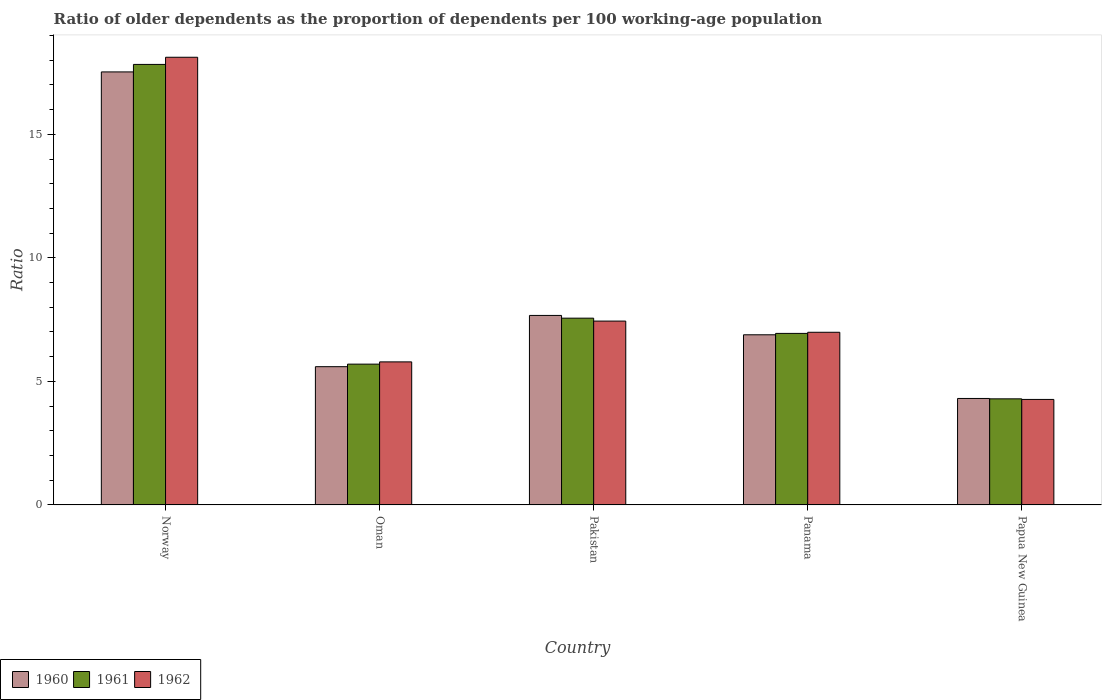How many different coloured bars are there?
Your answer should be very brief. 3. Are the number of bars per tick equal to the number of legend labels?
Provide a succinct answer. Yes. Are the number of bars on each tick of the X-axis equal?
Your response must be concise. Yes. How many bars are there on the 3rd tick from the left?
Offer a very short reply. 3. What is the age dependency ratio(old) in 1961 in Oman?
Make the answer very short. 5.7. Across all countries, what is the maximum age dependency ratio(old) in 1960?
Your response must be concise. 17.53. Across all countries, what is the minimum age dependency ratio(old) in 1961?
Give a very brief answer. 4.29. In which country was the age dependency ratio(old) in 1961 minimum?
Offer a terse response. Papua New Guinea. What is the total age dependency ratio(old) in 1962 in the graph?
Your response must be concise. 42.61. What is the difference between the age dependency ratio(old) in 1962 in Oman and that in Pakistan?
Offer a very short reply. -1.65. What is the difference between the age dependency ratio(old) in 1960 in Papua New Guinea and the age dependency ratio(old) in 1961 in Norway?
Make the answer very short. -13.52. What is the average age dependency ratio(old) in 1962 per country?
Your answer should be very brief. 8.52. What is the difference between the age dependency ratio(old) of/in 1960 and age dependency ratio(old) of/in 1961 in Panama?
Your answer should be very brief. -0.06. In how many countries, is the age dependency ratio(old) in 1960 greater than 18?
Offer a very short reply. 0. What is the ratio of the age dependency ratio(old) in 1961 in Pakistan to that in Papua New Guinea?
Offer a very short reply. 1.76. Is the age dependency ratio(old) in 1962 in Norway less than that in Panama?
Offer a very short reply. No. What is the difference between the highest and the second highest age dependency ratio(old) in 1960?
Provide a succinct answer. 10.64. What is the difference between the highest and the lowest age dependency ratio(old) in 1960?
Your answer should be very brief. 13.22. In how many countries, is the age dependency ratio(old) in 1962 greater than the average age dependency ratio(old) in 1962 taken over all countries?
Your answer should be compact. 1. What does the 3rd bar from the right in Oman represents?
Offer a very short reply. 1960. Are all the bars in the graph horizontal?
Make the answer very short. No. How many countries are there in the graph?
Your response must be concise. 5. Are the values on the major ticks of Y-axis written in scientific E-notation?
Your response must be concise. No. Does the graph contain grids?
Offer a very short reply. No. How are the legend labels stacked?
Provide a short and direct response. Horizontal. What is the title of the graph?
Provide a succinct answer. Ratio of older dependents as the proportion of dependents per 100 working-age population. What is the label or title of the Y-axis?
Keep it short and to the point. Ratio. What is the Ratio in 1960 in Norway?
Your response must be concise. 17.53. What is the Ratio of 1961 in Norway?
Keep it short and to the point. 17.83. What is the Ratio in 1962 in Norway?
Make the answer very short. 18.12. What is the Ratio in 1960 in Oman?
Offer a very short reply. 5.6. What is the Ratio in 1961 in Oman?
Your answer should be compact. 5.7. What is the Ratio of 1962 in Oman?
Give a very brief answer. 5.79. What is the Ratio in 1960 in Pakistan?
Provide a succinct answer. 7.67. What is the Ratio of 1961 in Pakistan?
Provide a short and direct response. 7.56. What is the Ratio in 1962 in Pakistan?
Ensure brevity in your answer.  7.44. What is the Ratio of 1960 in Panama?
Provide a succinct answer. 6.89. What is the Ratio of 1961 in Panama?
Your answer should be very brief. 6.94. What is the Ratio in 1962 in Panama?
Your answer should be compact. 6.99. What is the Ratio of 1960 in Papua New Guinea?
Your answer should be compact. 4.31. What is the Ratio of 1961 in Papua New Guinea?
Give a very brief answer. 4.29. What is the Ratio of 1962 in Papua New Guinea?
Offer a very short reply. 4.27. Across all countries, what is the maximum Ratio of 1960?
Ensure brevity in your answer.  17.53. Across all countries, what is the maximum Ratio of 1961?
Offer a very short reply. 17.83. Across all countries, what is the maximum Ratio of 1962?
Offer a terse response. 18.12. Across all countries, what is the minimum Ratio of 1960?
Your answer should be very brief. 4.31. Across all countries, what is the minimum Ratio in 1961?
Your answer should be compact. 4.29. Across all countries, what is the minimum Ratio in 1962?
Offer a terse response. 4.27. What is the total Ratio of 1960 in the graph?
Provide a succinct answer. 41.99. What is the total Ratio in 1961 in the graph?
Provide a succinct answer. 42.33. What is the total Ratio of 1962 in the graph?
Your answer should be compact. 42.61. What is the difference between the Ratio in 1960 in Norway and that in Oman?
Your answer should be compact. 11.93. What is the difference between the Ratio in 1961 in Norway and that in Oman?
Offer a terse response. 12.13. What is the difference between the Ratio of 1962 in Norway and that in Oman?
Your answer should be very brief. 12.33. What is the difference between the Ratio in 1960 in Norway and that in Pakistan?
Your answer should be compact. 9.86. What is the difference between the Ratio in 1961 in Norway and that in Pakistan?
Offer a very short reply. 10.27. What is the difference between the Ratio in 1962 in Norway and that in Pakistan?
Ensure brevity in your answer.  10.68. What is the difference between the Ratio of 1960 in Norway and that in Panama?
Provide a succinct answer. 10.64. What is the difference between the Ratio in 1961 in Norway and that in Panama?
Keep it short and to the point. 10.89. What is the difference between the Ratio in 1962 in Norway and that in Panama?
Your response must be concise. 11.13. What is the difference between the Ratio in 1960 in Norway and that in Papua New Guinea?
Make the answer very short. 13.22. What is the difference between the Ratio of 1961 in Norway and that in Papua New Guinea?
Make the answer very short. 13.54. What is the difference between the Ratio of 1962 in Norway and that in Papua New Guinea?
Offer a very short reply. 13.85. What is the difference between the Ratio of 1960 in Oman and that in Pakistan?
Ensure brevity in your answer.  -2.07. What is the difference between the Ratio in 1961 in Oman and that in Pakistan?
Provide a short and direct response. -1.86. What is the difference between the Ratio of 1962 in Oman and that in Pakistan?
Make the answer very short. -1.65. What is the difference between the Ratio of 1960 in Oman and that in Panama?
Provide a short and direct response. -1.29. What is the difference between the Ratio of 1961 in Oman and that in Panama?
Make the answer very short. -1.24. What is the difference between the Ratio in 1962 in Oman and that in Panama?
Provide a short and direct response. -1.2. What is the difference between the Ratio in 1960 in Oman and that in Papua New Guinea?
Make the answer very short. 1.29. What is the difference between the Ratio of 1961 in Oman and that in Papua New Guinea?
Offer a very short reply. 1.4. What is the difference between the Ratio of 1962 in Oman and that in Papua New Guinea?
Offer a very short reply. 1.52. What is the difference between the Ratio in 1960 in Pakistan and that in Panama?
Your answer should be very brief. 0.78. What is the difference between the Ratio of 1961 in Pakistan and that in Panama?
Your response must be concise. 0.62. What is the difference between the Ratio of 1962 in Pakistan and that in Panama?
Provide a short and direct response. 0.45. What is the difference between the Ratio in 1960 in Pakistan and that in Papua New Guinea?
Provide a succinct answer. 3.36. What is the difference between the Ratio in 1961 in Pakistan and that in Papua New Guinea?
Offer a terse response. 3.27. What is the difference between the Ratio of 1962 in Pakistan and that in Papua New Guinea?
Offer a terse response. 3.17. What is the difference between the Ratio of 1960 in Panama and that in Papua New Guinea?
Your answer should be very brief. 2.58. What is the difference between the Ratio of 1961 in Panama and that in Papua New Guinea?
Offer a very short reply. 2.65. What is the difference between the Ratio in 1962 in Panama and that in Papua New Guinea?
Give a very brief answer. 2.72. What is the difference between the Ratio of 1960 in Norway and the Ratio of 1961 in Oman?
Your answer should be very brief. 11.83. What is the difference between the Ratio in 1960 in Norway and the Ratio in 1962 in Oman?
Offer a very short reply. 11.74. What is the difference between the Ratio in 1961 in Norway and the Ratio in 1962 in Oman?
Offer a very short reply. 12.04. What is the difference between the Ratio in 1960 in Norway and the Ratio in 1961 in Pakistan?
Provide a short and direct response. 9.97. What is the difference between the Ratio of 1960 in Norway and the Ratio of 1962 in Pakistan?
Ensure brevity in your answer.  10.09. What is the difference between the Ratio in 1961 in Norway and the Ratio in 1962 in Pakistan?
Your answer should be compact. 10.39. What is the difference between the Ratio of 1960 in Norway and the Ratio of 1961 in Panama?
Ensure brevity in your answer.  10.58. What is the difference between the Ratio of 1960 in Norway and the Ratio of 1962 in Panama?
Keep it short and to the point. 10.54. What is the difference between the Ratio of 1961 in Norway and the Ratio of 1962 in Panama?
Offer a very short reply. 10.84. What is the difference between the Ratio in 1960 in Norway and the Ratio in 1961 in Papua New Guinea?
Your answer should be compact. 13.23. What is the difference between the Ratio of 1960 in Norway and the Ratio of 1962 in Papua New Guinea?
Ensure brevity in your answer.  13.26. What is the difference between the Ratio of 1961 in Norway and the Ratio of 1962 in Papua New Guinea?
Provide a short and direct response. 13.56. What is the difference between the Ratio of 1960 in Oman and the Ratio of 1961 in Pakistan?
Keep it short and to the point. -1.96. What is the difference between the Ratio of 1960 in Oman and the Ratio of 1962 in Pakistan?
Ensure brevity in your answer.  -1.85. What is the difference between the Ratio of 1961 in Oman and the Ratio of 1962 in Pakistan?
Provide a short and direct response. -1.74. What is the difference between the Ratio in 1960 in Oman and the Ratio in 1961 in Panama?
Offer a terse response. -1.35. What is the difference between the Ratio in 1960 in Oman and the Ratio in 1962 in Panama?
Give a very brief answer. -1.39. What is the difference between the Ratio of 1961 in Oman and the Ratio of 1962 in Panama?
Offer a very short reply. -1.29. What is the difference between the Ratio of 1960 in Oman and the Ratio of 1961 in Papua New Guinea?
Your response must be concise. 1.3. What is the difference between the Ratio of 1960 in Oman and the Ratio of 1962 in Papua New Guinea?
Your answer should be very brief. 1.33. What is the difference between the Ratio in 1961 in Oman and the Ratio in 1962 in Papua New Guinea?
Your answer should be very brief. 1.43. What is the difference between the Ratio in 1960 in Pakistan and the Ratio in 1961 in Panama?
Provide a short and direct response. 0.73. What is the difference between the Ratio of 1960 in Pakistan and the Ratio of 1962 in Panama?
Ensure brevity in your answer.  0.68. What is the difference between the Ratio in 1961 in Pakistan and the Ratio in 1962 in Panama?
Ensure brevity in your answer.  0.57. What is the difference between the Ratio in 1960 in Pakistan and the Ratio in 1961 in Papua New Guinea?
Provide a short and direct response. 3.38. What is the difference between the Ratio of 1960 in Pakistan and the Ratio of 1962 in Papua New Guinea?
Keep it short and to the point. 3.4. What is the difference between the Ratio in 1961 in Pakistan and the Ratio in 1962 in Papua New Guinea?
Keep it short and to the point. 3.29. What is the difference between the Ratio in 1960 in Panama and the Ratio in 1961 in Papua New Guinea?
Make the answer very short. 2.59. What is the difference between the Ratio in 1960 in Panama and the Ratio in 1962 in Papua New Guinea?
Your answer should be compact. 2.62. What is the difference between the Ratio of 1961 in Panama and the Ratio of 1962 in Papua New Guinea?
Give a very brief answer. 2.67. What is the average Ratio in 1960 per country?
Make the answer very short. 8.4. What is the average Ratio in 1961 per country?
Offer a terse response. 8.47. What is the average Ratio of 1962 per country?
Keep it short and to the point. 8.52. What is the difference between the Ratio of 1960 and Ratio of 1961 in Norway?
Offer a terse response. -0.3. What is the difference between the Ratio of 1960 and Ratio of 1962 in Norway?
Offer a terse response. -0.59. What is the difference between the Ratio in 1961 and Ratio in 1962 in Norway?
Your answer should be compact. -0.29. What is the difference between the Ratio in 1960 and Ratio in 1961 in Oman?
Your response must be concise. -0.1. What is the difference between the Ratio in 1960 and Ratio in 1962 in Oman?
Your response must be concise. -0.19. What is the difference between the Ratio in 1961 and Ratio in 1962 in Oman?
Offer a terse response. -0.09. What is the difference between the Ratio of 1960 and Ratio of 1961 in Pakistan?
Offer a very short reply. 0.11. What is the difference between the Ratio of 1960 and Ratio of 1962 in Pakistan?
Offer a very short reply. 0.23. What is the difference between the Ratio in 1961 and Ratio in 1962 in Pakistan?
Keep it short and to the point. 0.12. What is the difference between the Ratio of 1960 and Ratio of 1961 in Panama?
Offer a very short reply. -0.06. What is the difference between the Ratio of 1960 and Ratio of 1962 in Panama?
Offer a terse response. -0.1. What is the difference between the Ratio of 1961 and Ratio of 1962 in Panama?
Make the answer very short. -0.05. What is the difference between the Ratio in 1960 and Ratio in 1961 in Papua New Guinea?
Provide a short and direct response. 0.02. What is the difference between the Ratio in 1960 and Ratio in 1962 in Papua New Guinea?
Ensure brevity in your answer.  0.04. What is the difference between the Ratio of 1961 and Ratio of 1962 in Papua New Guinea?
Your answer should be compact. 0.02. What is the ratio of the Ratio of 1960 in Norway to that in Oman?
Your answer should be compact. 3.13. What is the ratio of the Ratio of 1961 in Norway to that in Oman?
Provide a short and direct response. 3.13. What is the ratio of the Ratio of 1962 in Norway to that in Oman?
Your answer should be compact. 3.13. What is the ratio of the Ratio in 1960 in Norway to that in Pakistan?
Your answer should be very brief. 2.28. What is the ratio of the Ratio in 1961 in Norway to that in Pakistan?
Offer a terse response. 2.36. What is the ratio of the Ratio of 1962 in Norway to that in Pakistan?
Your answer should be very brief. 2.44. What is the ratio of the Ratio of 1960 in Norway to that in Panama?
Make the answer very short. 2.55. What is the ratio of the Ratio of 1961 in Norway to that in Panama?
Your answer should be very brief. 2.57. What is the ratio of the Ratio of 1962 in Norway to that in Panama?
Keep it short and to the point. 2.59. What is the ratio of the Ratio of 1960 in Norway to that in Papua New Guinea?
Provide a short and direct response. 4.07. What is the ratio of the Ratio in 1961 in Norway to that in Papua New Guinea?
Provide a short and direct response. 4.15. What is the ratio of the Ratio in 1962 in Norway to that in Papua New Guinea?
Make the answer very short. 4.24. What is the ratio of the Ratio of 1960 in Oman to that in Pakistan?
Provide a succinct answer. 0.73. What is the ratio of the Ratio of 1961 in Oman to that in Pakistan?
Your answer should be compact. 0.75. What is the ratio of the Ratio of 1962 in Oman to that in Pakistan?
Make the answer very short. 0.78. What is the ratio of the Ratio in 1960 in Oman to that in Panama?
Make the answer very short. 0.81. What is the ratio of the Ratio in 1961 in Oman to that in Panama?
Offer a terse response. 0.82. What is the ratio of the Ratio in 1962 in Oman to that in Panama?
Give a very brief answer. 0.83. What is the ratio of the Ratio in 1960 in Oman to that in Papua New Guinea?
Offer a very short reply. 1.3. What is the ratio of the Ratio in 1961 in Oman to that in Papua New Guinea?
Your response must be concise. 1.33. What is the ratio of the Ratio in 1962 in Oman to that in Papua New Guinea?
Provide a succinct answer. 1.36. What is the ratio of the Ratio of 1960 in Pakistan to that in Panama?
Your response must be concise. 1.11. What is the ratio of the Ratio of 1961 in Pakistan to that in Panama?
Offer a terse response. 1.09. What is the ratio of the Ratio of 1962 in Pakistan to that in Panama?
Give a very brief answer. 1.06. What is the ratio of the Ratio in 1960 in Pakistan to that in Papua New Guinea?
Provide a short and direct response. 1.78. What is the ratio of the Ratio in 1961 in Pakistan to that in Papua New Guinea?
Your answer should be very brief. 1.76. What is the ratio of the Ratio of 1962 in Pakistan to that in Papua New Guinea?
Offer a terse response. 1.74. What is the ratio of the Ratio in 1960 in Panama to that in Papua New Guinea?
Keep it short and to the point. 1.6. What is the ratio of the Ratio of 1961 in Panama to that in Papua New Guinea?
Offer a terse response. 1.62. What is the ratio of the Ratio in 1962 in Panama to that in Papua New Guinea?
Provide a succinct answer. 1.64. What is the difference between the highest and the second highest Ratio in 1960?
Make the answer very short. 9.86. What is the difference between the highest and the second highest Ratio in 1961?
Ensure brevity in your answer.  10.27. What is the difference between the highest and the second highest Ratio of 1962?
Offer a terse response. 10.68. What is the difference between the highest and the lowest Ratio in 1960?
Keep it short and to the point. 13.22. What is the difference between the highest and the lowest Ratio of 1961?
Your response must be concise. 13.54. What is the difference between the highest and the lowest Ratio of 1962?
Your answer should be compact. 13.85. 